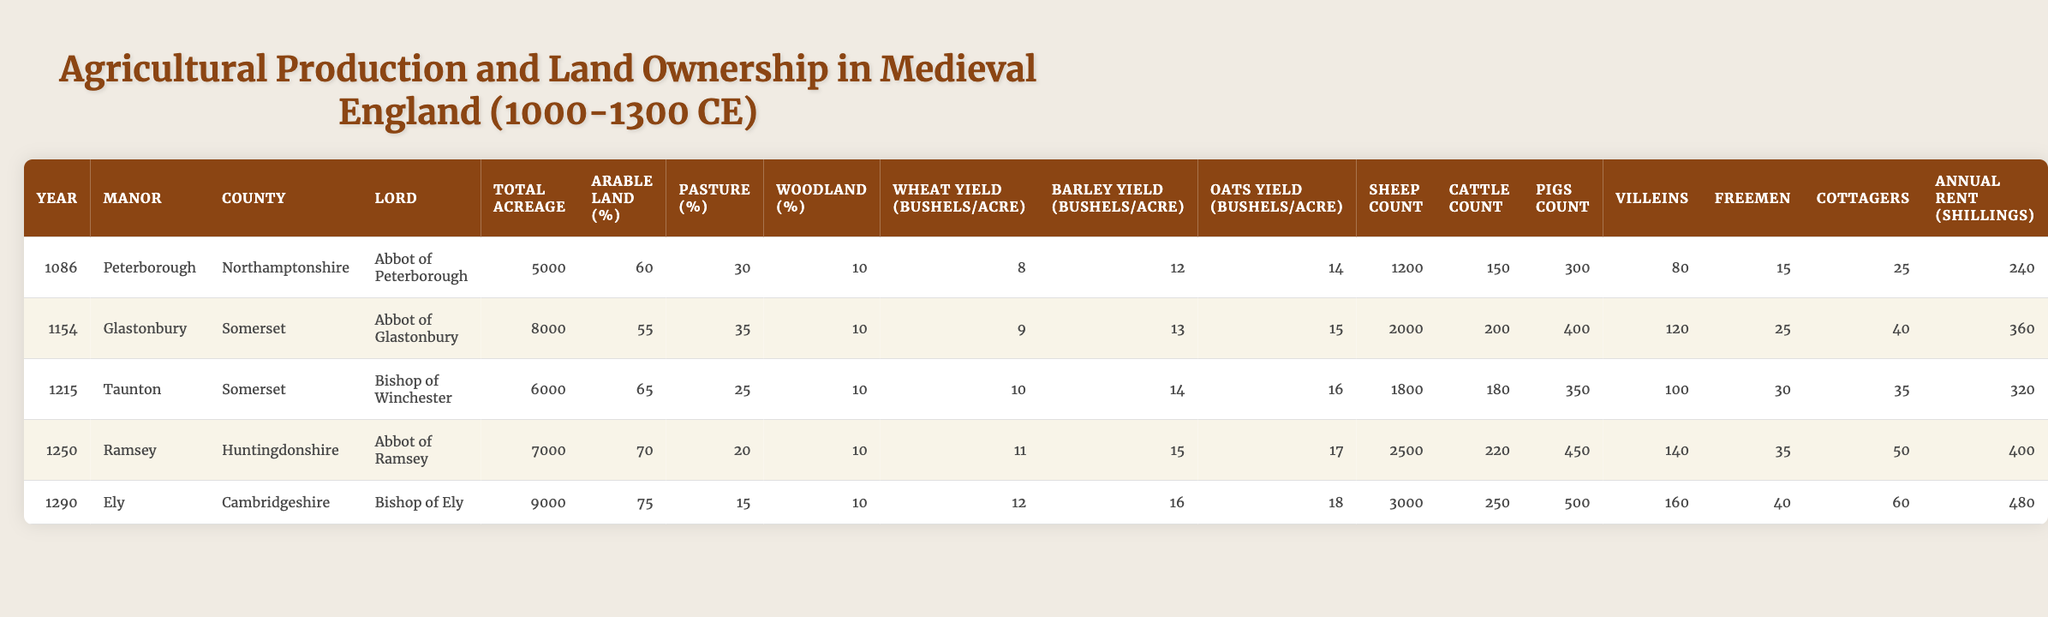What is the total acreage of the manor "Ramsey"? The data shows the "Total Acreage" for the manor "Ramsey" is listed as 7000.
Answer: 7000 How many sheep were counted in "Ely"? The row for "Ely" indicates a "Sheep Count" of 3000.
Answer: 3000 Which manor had the highest wheat yield per acre? By comparing the "Wheat Yield (bushels/acre)", "Ely" has the highest yield at 12 bushels per acre.
Answer: Ely What is the percentage of arable land in the manor "Taunton"? The table lists the "Arable Land (%)" specifically for "Taunton" as 65%.
Answer: 65% How many more villeins were in "Ramsey" than in "Peterborough"? "Ramsey" has 140 villeins while "Peterborough" has 80; therefore, the difference is 140 - 80 = 60.
Answer: 60 What is the total number of animals (sheep, cattle, pigs) on the manor "Glastonbury"? Adding the counts: 2000 sheep + 200 cattle + 400 pigs = 2600 total animals in "Glastonbury".
Answer: 2600 True or False: The lord of "Taunton" was the Abbot of Glastonbury. According to the table, the lord of "Taunton" is the Bishop of Winchester, not the Abbot of Glastonbury.
Answer: False Which manor had the lowest percentage of pasture land? Analyzing the "Pasture (%)" values reveals that "Ely" has the lowest at 15%.
Answer: Ely Calculate the average annual rent for manors listed from 1086 to 1290. The annual rents are 240, 360, 320, 400, and 480 shillings. Adding these gives 240 + 360 + 320 + 400 + 480 = 1800 shillings. Dividing by 5 manors yields an average of 1800 / 5 = 360.
Answer: 360 What was the total count of freemen across all manors? Adding the "Freemen" counts gives: 15 (Peterborough) + 25 (Glastonbury) + 30 (Taunton) + 35 (Ramsey) + 40 (Ely) = 135 freemen.
Answer: 135 